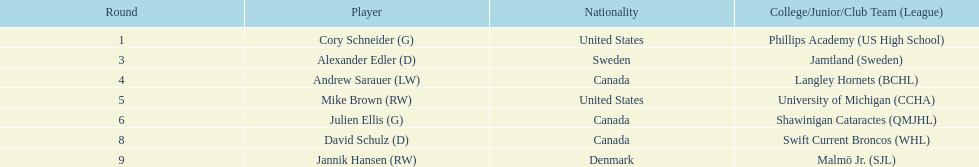Which sportspeople are not danish natives? Cory Schneider (G), Alexander Edler (D), Andrew Sarauer (LW), Mike Brown (RW), Julien Ellis (G), David Schulz (D). 